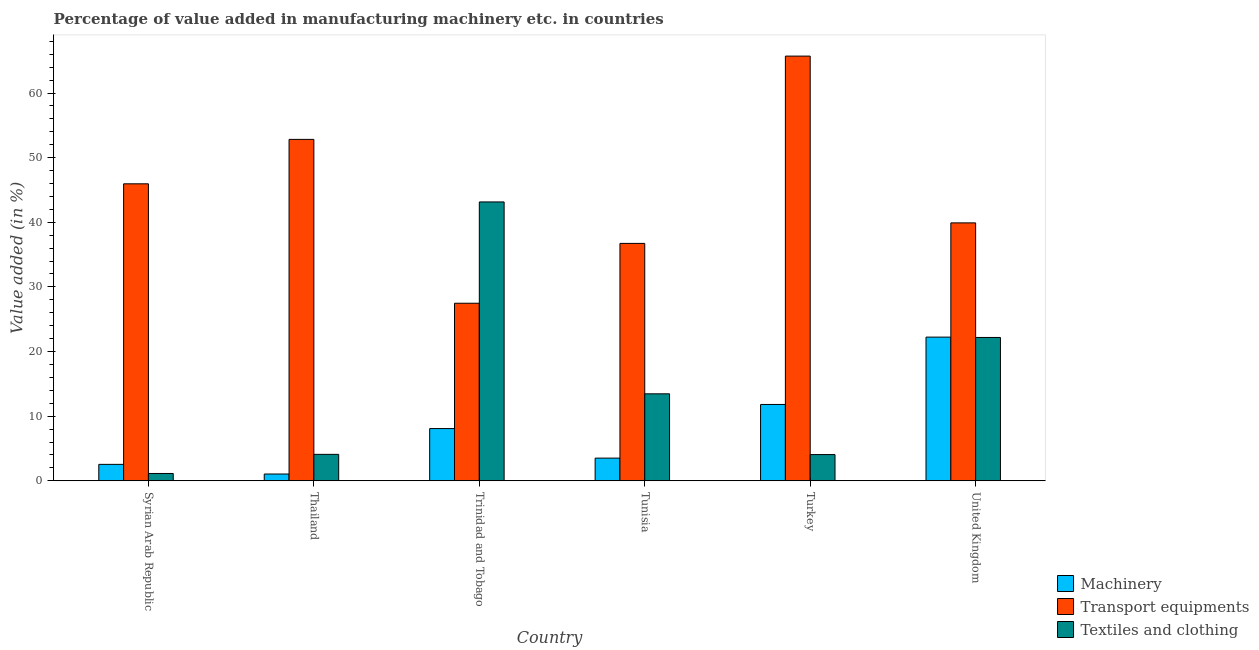How many groups of bars are there?
Provide a short and direct response. 6. Are the number of bars per tick equal to the number of legend labels?
Provide a short and direct response. Yes. Are the number of bars on each tick of the X-axis equal?
Make the answer very short. Yes. How many bars are there on the 5th tick from the right?
Offer a terse response. 3. What is the label of the 4th group of bars from the left?
Provide a succinct answer. Tunisia. In how many cases, is the number of bars for a given country not equal to the number of legend labels?
Ensure brevity in your answer.  0. What is the value added in manufacturing machinery in Trinidad and Tobago?
Give a very brief answer. 8.08. Across all countries, what is the maximum value added in manufacturing textile and clothing?
Your answer should be very brief. 43.15. Across all countries, what is the minimum value added in manufacturing transport equipments?
Offer a terse response. 27.47. In which country was the value added in manufacturing transport equipments maximum?
Your answer should be compact. Turkey. In which country was the value added in manufacturing machinery minimum?
Provide a succinct answer. Thailand. What is the total value added in manufacturing textile and clothing in the graph?
Provide a short and direct response. 88.06. What is the difference between the value added in manufacturing transport equipments in Syrian Arab Republic and that in Thailand?
Make the answer very short. -6.88. What is the difference between the value added in manufacturing textile and clothing in Syrian Arab Republic and the value added in manufacturing machinery in Turkey?
Keep it short and to the point. -10.68. What is the average value added in manufacturing transport equipments per country?
Make the answer very short. 44.77. What is the difference between the value added in manufacturing transport equipments and value added in manufacturing machinery in Tunisia?
Offer a very short reply. 33.23. In how many countries, is the value added in manufacturing textile and clothing greater than 60 %?
Give a very brief answer. 0. What is the ratio of the value added in manufacturing machinery in Syrian Arab Republic to that in Tunisia?
Ensure brevity in your answer.  0.72. Is the value added in manufacturing machinery in Syrian Arab Republic less than that in Tunisia?
Ensure brevity in your answer.  Yes. What is the difference between the highest and the second highest value added in manufacturing textile and clothing?
Your answer should be compact. 20.97. What is the difference between the highest and the lowest value added in manufacturing machinery?
Offer a terse response. 21.19. Is the sum of the value added in manufacturing textile and clothing in Syrian Arab Republic and Trinidad and Tobago greater than the maximum value added in manufacturing transport equipments across all countries?
Offer a very short reply. No. What does the 3rd bar from the left in Trinidad and Tobago represents?
Keep it short and to the point. Textiles and clothing. What does the 2nd bar from the right in United Kingdom represents?
Offer a very short reply. Transport equipments. How many bars are there?
Your answer should be compact. 18. Are all the bars in the graph horizontal?
Make the answer very short. No. How many countries are there in the graph?
Make the answer very short. 6. What is the difference between two consecutive major ticks on the Y-axis?
Your answer should be very brief. 10. Are the values on the major ticks of Y-axis written in scientific E-notation?
Give a very brief answer. No. Does the graph contain any zero values?
Provide a succinct answer. No. Does the graph contain grids?
Your response must be concise. No. Where does the legend appear in the graph?
Your answer should be compact. Bottom right. What is the title of the graph?
Ensure brevity in your answer.  Percentage of value added in manufacturing machinery etc. in countries. What is the label or title of the X-axis?
Provide a short and direct response. Country. What is the label or title of the Y-axis?
Make the answer very short. Value added (in %). What is the Value added (in %) of Machinery in Syrian Arab Republic?
Offer a very short reply. 2.54. What is the Value added (in %) in Transport equipments in Syrian Arab Republic?
Ensure brevity in your answer.  45.95. What is the Value added (in %) in Textiles and clothing in Syrian Arab Republic?
Your response must be concise. 1.13. What is the Value added (in %) of Machinery in Thailand?
Your answer should be compact. 1.05. What is the Value added (in %) in Transport equipments in Thailand?
Offer a terse response. 52.83. What is the Value added (in %) in Textiles and clothing in Thailand?
Offer a terse response. 4.09. What is the Value added (in %) of Machinery in Trinidad and Tobago?
Make the answer very short. 8.08. What is the Value added (in %) of Transport equipments in Trinidad and Tobago?
Provide a succinct answer. 27.47. What is the Value added (in %) in Textiles and clothing in Trinidad and Tobago?
Provide a succinct answer. 43.15. What is the Value added (in %) of Machinery in Tunisia?
Your answer should be very brief. 3.51. What is the Value added (in %) in Transport equipments in Tunisia?
Provide a short and direct response. 36.73. What is the Value added (in %) of Textiles and clothing in Tunisia?
Give a very brief answer. 13.46. What is the Value added (in %) in Machinery in Turkey?
Give a very brief answer. 11.81. What is the Value added (in %) of Transport equipments in Turkey?
Give a very brief answer. 65.71. What is the Value added (in %) in Textiles and clothing in Turkey?
Give a very brief answer. 4.06. What is the Value added (in %) in Machinery in United Kingdom?
Provide a succinct answer. 22.23. What is the Value added (in %) in Transport equipments in United Kingdom?
Your response must be concise. 39.91. What is the Value added (in %) in Textiles and clothing in United Kingdom?
Provide a short and direct response. 22.18. Across all countries, what is the maximum Value added (in %) of Machinery?
Your answer should be compact. 22.23. Across all countries, what is the maximum Value added (in %) of Transport equipments?
Ensure brevity in your answer.  65.71. Across all countries, what is the maximum Value added (in %) of Textiles and clothing?
Your answer should be compact. 43.15. Across all countries, what is the minimum Value added (in %) of Machinery?
Provide a short and direct response. 1.05. Across all countries, what is the minimum Value added (in %) in Transport equipments?
Provide a succinct answer. 27.47. Across all countries, what is the minimum Value added (in %) of Textiles and clothing?
Keep it short and to the point. 1.13. What is the total Value added (in %) of Machinery in the graph?
Ensure brevity in your answer.  49.22. What is the total Value added (in %) of Transport equipments in the graph?
Your answer should be very brief. 268.61. What is the total Value added (in %) of Textiles and clothing in the graph?
Provide a succinct answer. 88.06. What is the difference between the Value added (in %) of Machinery in Syrian Arab Republic and that in Thailand?
Offer a terse response. 1.49. What is the difference between the Value added (in %) in Transport equipments in Syrian Arab Republic and that in Thailand?
Your answer should be very brief. -6.88. What is the difference between the Value added (in %) in Textiles and clothing in Syrian Arab Republic and that in Thailand?
Make the answer very short. -2.96. What is the difference between the Value added (in %) in Machinery in Syrian Arab Republic and that in Trinidad and Tobago?
Keep it short and to the point. -5.54. What is the difference between the Value added (in %) in Transport equipments in Syrian Arab Republic and that in Trinidad and Tobago?
Ensure brevity in your answer.  18.48. What is the difference between the Value added (in %) of Textiles and clothing in Syrian Arab Republic and that in Trinidad and Tobago?
Ensure brevity in your answer.  -42.02. What is the difference between the Value added (in %) in Machinery in Syrian Arab Republic and that in Tunisia?
Your answer should be very brief. -0.97. What is the difference between the Value added (in %) in Transport equipments in Syrian Arab Republic and that in Tunisia?
Offer a very short reply. 9.22. What is the difference between the Value added (in %) of Textiles and clothing in Syrian Arab Republic and that in Tunisia?
Ensure brevity in your answer.  -12.32. What is the difference between the Value added (in %) in Machinery in Syrian Arab Republic and that in Turkey?
Your answer should be very brief. -9.27. What is the difference between the Value added (in %) of Transport equipments in Syrian Arab Republic and that in Turkey?
Your answer should be very brief. -19.76. What is the difference between the Value added (in %) in Textiles and clothing in Syrian Arab Republic and that in Turkey?
Give a very brief answer. -2.92. What is the difference between the Value added (in %) of Machinery in Syrian Arab Republic and that in United Kingdom?
Provide a succinct answer. -19.69. What is the difference between the Value added (in %) of Transport equipments in Syrian Arab Republic and that in United Kingdom?
Give a very brief answer. 6.04. What is the difference between the Value added (in %) of Textiles and clothing in Syrian Arab Republic and that in United Kingdom?
Provide a short and direct response. -21.05. What is the difference between the Value added (in %) of Machinery in Thailand and that in Trinidad and Tobago?
Your answer should be compact. -7.03. What is the difference between the Value added (in %) in Transport equipments in Thailand and that in Trinidad and Tobago?
Ensure brevity in your answer.  25.36. What is the difference between the Value added (in %) of Textiles and clothing in Thailand and that in Trinidad and Tobago?
Your response must be concise. -39.06. What is the difference between the Value added (in %) in Machinery in Thailand and that in Tunisia?
Ensure brevity in your answer.  -2.46. What is the difference between the Value added (in %) in Transport equipments in Thailand and that in Tunisia?
Offer a very short reply. 16.1. What is the difference between the Value added (in %) in Textiles and clothing in Thailand and that in Tunisia?
Keep it short and to the point. -9.36. What is the difference between the Value added (in %) in Machinery in Thailand and that in Turkey?
Offer a terse response. -10.76. What is the difference between the Value added (in %) in Transport equipments in Thailand and that in Turkey?
Provide a short and direct response. -12.88. What is the difference between the Value added (in %) of Textiles and clothing in Thailand and that in Turkey?
Provide a short and direct response. 0.03. What is the difference between the Value added (in %) in Machinery in Thailand and that in United Kingdom?
Your response must be concise. -21.19. What is the difference between the Value added (in %) in Transport equipments in Thailand and that in United Kingdom?
Make the answer very short. 12.92. What is the difference between the Value added (in %) of Textiles and clothing in Thailand and that in United Kingdom?
Your answer should be compact. -18.09. What is the difference between the Value added (in %) of Machinery in Trinidad and Tobago and that in Tunisia?
Make the answer very short. 4.57. What is the difference between the Value added (in %) of Transport equipments in Trinidad and Tobago and that in Tunisia?
Your answer should be very brief. -9.26. What is the difference between the Value added (in %) of Textiles and clothing in Trinidad and Tobago and that in Tunisia?
Provide a succinct answer. 29.69. What is the difference between the Value added (in %) in Machinery in Trinidad and Tobago and that in Turkey?
Make the answer very short. -3.73. What is the difference between the Value added (in %) of Transport equipments in Trinidad and Tobago and that in Turkey?
Ensure brevity in your answer.  -38.24. What is the difference between the Value added (in %) in Textiles and clothing in Trinidad and Tobago and that in Turkey?
Give a very brief answer. 39.09. What is the difference between the Value added (in %) in Machinery in Trinidad and Tobago and that in United Kingdom?
Your answer should be compact. -14.15. What is the difference between the Value added (in %) of Transport equipments in Trinidad and Tobago and that in United Kingdom?
Your answer should be compact. -12.44. What is the difference between the Value added (in %) in Textiles and clothing in Trinidad and Tobago and that in United Kingdom?
Provide a succinct answer. 20.97. What is the difference between the Value added (in %) in Machinery in Tunisia and that in Turkey?
Make the answer very short. -8.3. What is the difference between the Value added (in %) of Transport equipments in Tunisia and that in Turkey?
Offer a terse response. -28.98. What is the difference between the Value added (in %) of Textiles and clothing in Tunisia and that in Turkey?
Provide a short and direct response. 9.4. What is the difference between the Value added (in %) in Machinery in Tunisia and that in United Kingdom?
Your response must be concise. -18.73. What is the difference between the Value added (in %) of Transport equipments in Tunisia and that in United Kingdom?
Make the answer very short. -3.17. What is the difference between the Value added (in %) of Textiles and clothing in Tunisia and that in United Kingdom?
Provide a succinct answer. -8.72. What is the difference between the Value added (in %) of Machinery in Turkey and that in United Kingdom?
Ensure brevity in your answer.  -10.42. What is the difference between the Value added (in %) in Transport equipments in Turkey and that in United Kingdom?
Offer a terse response. 25.81. What is the difference between the Value added (in %) of Textiles and clothing in Turkey and that in United Kingdom?
Your answer should be compact. -18.12. What is the difference between the Value added (in %) in Machinery in Syrian Arab Republic and the Value added (in %) in Transport equipments in Thailand?
Give a very brief answer. -50.29. What is the difference between the Value added (in %) in Machinery in Syrian Arab Republic and the Value added (in %) in Textiles and clothing in Thailand?
Offer a very short reply. -1.55. What is the difference between the Value added (in %) of Transport equipments in Syrian Arab Republic and the Value added (in %) of Textiles and clothing in Thailand?
Your answer should be very brief. 41.86. What is the difference between the Value added (in %) in Machinery in Syrian Arab Republic and the Value added (in %) in Transport equipments in Trinidad and Tobago?
Your answer should be compact. -24.93. What is the difference between the Value added (in %) of Machinery in Syrian Arab Republic and the Value added (in %) of Textiles and clothing in Trinidad and Tobago?
Your response must be concise. -40.61. What is the difference between the Value added (in %) of Transport equipments in Syrian Arab Republic and the Value added (in %) of Textiles and clothing in Trinidad and Tobago?
Keep it short and to the point. 2.8. What is the difference between the Value added (in %) in Machinery in Syrian Arab Republic and the Value added (in %) in Transport equipments in Tunisia?
Make the answer very short. -34.19. What is the difference between the Value added (in %) of Machinery in Syrian Arab Republic and the Value added (in %) of Textiles and clothing in Tunisia?
Your answer should be compact. -10.92. What is the difference between the Value added (in %) of Transport equipments in Syrian Arab Republic and the Value added (in %) of Textiles and clothing in Tunisia?
Make the answer very short. 32.5. What is the difference between the Value added (in %) of Machinery in Syrian Arab Republic and the Value added (in %) of Transport equipments in Turkey?
Your answer should be very brief. -63.17. What is the difference between the Value added (in %) in Machinery in Syrian Arab Republic and the Value added (in %) in Textiles and clothing in Turkey?
Give a very brief answer. -1.52. What is the difference between the Value added (in %) in Transport equipments in Syrian Arab Republic and the Value added (in %) in Textiles and clothing in Turkey?
Your answer should be very brief. 41.9. What is the difference between the Value added (in %) in Machinery in Syrian Arab Republic and the Value added (in %) in Transport equipments in United Kingdom?
Provide a short and direct response. -37.37. What is the difference between the Value added (in %) of Machinery in Syrian Arab Republic and the Value added (in %) of Textiles and clothing in United Kingdom?
Provide a short and direct response. -19.64. What is the difference between the Value added (in %) in Transport equipments in Syrian Arab Republic and the Value added (in %) in Textiles and clothing in United Kingdom?
Provide a short and direct response. 23.77. What is the difference between the Value added (in %) of Machinery in Thailand and the Value added (in %) of Transport equipments in Trinidad and Tobago?
Your answer should be very brief. -26.43. What is the difference between the Value added (in %) in Machinery in Thailand and the Value added (in %) in Textiles and clothing in Trinidad and Tobago?
Make the answer very short. -42.1. What is the difference between the Value added (in %) of Transport equipments in Thailand and the Value added (in %) of Textiles and clothing in Trinidad and Tobago?
Make the answer very short. 9.68. What is the difference between the Value added (in %) in Machinery in Thailand and the Value added (in %) in Transport equipments in Tunisia?
Ensure brevity in your answer.  -35.69. What is the difference between the Value added (in %) in Machinery in Thailand and the Value added (in %) in Textiles and clothing in Tunisia?
Offer a very short reply. -12.41. What is the difference between the Value added (in %) in Transport equipments in Thailand and the Value added (in %) in Textiles and clothing in Tunisia?
Your response must be concise. 39.37. What is the difference between the Value added (in %) in Machinery in Thailand and the Value added (in %) in Transport equipments in Turkey?
Your answer should be compact. -64.67. What is the difference between the Value added (in %) of Machinery in Thailand and the Value added (in %) of Textiles and clothing in Turkey?
Offer a terse response. -3.01. What is the difference between the Value added (in %) of Transport equipments in Thailand and the Value added (in %) of Textiles and clothing in Turkey?
Your answer should be very brief. 48.77. What is the difference between the Value added (in %) of Machinery in Thailand and the Value added (in %) of Transport equipments in United Kingdom?
Offer a very short reply. -38.86. What is the difference between the Value added (in %) in Machinery in Thailand and the Value added (in %) in Textiles and clothing in United Kingdom?
Provide a succinct answer. -21.13. What is the difference between the Value added (in %) in Transport equipments in Thailand and the Value added (in %) in Textiles and clothing in United Kingdom?
Your answer should be very brief. 30.65. What is the difference between the Value added (in %) of Machinery in Trinidad and Tobago and the Value added (in %) of Transport equipments in Tunisia?
Provide a succinct answer. -28.65. What is the difference between the Value added (in %) in Machinery in Trinidad and Tobago and the Value added (in %) in Textiles and clothing in Tunisia?
Offer a very short reply. -5.38. What is the difference between the Value added (in %) of Transport equipments in Trinidad and Tobago and the Value added (in %) of Textiles and clothing in Tunisia?
Provide a succinct answer. 14.02. What is the difference between the Value added (in %) of Machinery in Trinidad and Tobago and the Value added (in %) of Transport equipments in Turkey?
Provide a short and direct response. -57.63. What is the difference between the Value added (in %) of Machinery in Trinidad and Tobago and the Value added (in %) of Textiles and clothing in Turkey?
Offer a terse response. 4.02. What is the difference between the Value added (in %) in Transport equipments in Trinidad and Tobago and the Value added (in %) in Textiles and clothing in Turkey?
Make the answer very short. 23.42. What is the difference between the Value added (in %) in Machinery in Trinidad and Tobago and the Value added (in %) in Transport equipments in United Kingdom?
Offer a terse response. -31.83. What is the difference between the Value added (in %) in Machinery in Trinidad and Tobago and the Value added (in %) in Textiles and clothing in United Kingdom?
Keep it short and to the point. -14.1. What is the difference between the Value added (in %) of Transport equipments in Trinidad and Tobago and the Value added (in %) of Textiles and clothing in United Kingdom?
Your answer should be compact. 5.3. What is the difference between the Value added (in %) in Machinery in Tunisia and the Value added (in %) in Transport equipments in Turkey?
Ensure brevity in your answer.  -62.21. What is the difference between the Value added (in %) in Machinery in Tunisia and the Value added (in %) in Textiles and clothing in Turkey?
Ensure brevity in your answer.  -0.55. What is the difference between the Value added (in %) of Transport equipments in Tunisia and the Value added (in %) of Textiles and clothing in Turkey?
Your response must be concise. 32.68. What is the difference between the Value added (in %) of Machinery in Tunisia and the Value added (in %) of Transport equipments in United Kingdom?
Give a very brief answer. -36.4. What is the difference between the Value added (in %) in Machinery in Tunisia and the Value added (in %) in Textiles and clothing in United Kingdom?
Keep it short and to the point. -18.67. What is the difference between the Value added (in %) of Transport equipments in Tunisia and the Value added (in %) of Textiles and clothing in United Kingdom?
Offer a terse response. 14.56. What is the difference between the Value added (in %) in Machinery in Turkey and the Value added (in %) in Transport equipments in United Kingdom?
Your answer should be compact. -28.1. What is the difference between the Value added (in %) of Machinery in Turkey and the Value added (in %) of Textiles and clothing in United Kingdom?
Give a very brief answer. -10.37. What is the difference between the Value added (in %) in Transport equipments in Turkey and the Value added (in %) in Textiles and clothing in United Kingdom?
Make the answer very short. 43.54. What is the average Value added (in %) in Machinery per country?
Offer a very short reply. 8.2. What is the average Value added (in %) in Transport equipments per country?
Provide a short and direct response. 44.77. What is the average Value added (in %) of Textiles and clothing per country?
Your answer should be compact. 14.68. What is the difference between the Value added (in %) of Machinery and Value added (in %) of Transport equipments in Syrian Arab Republic?
Make the answer very short. -43.41. What is the difference between the Value added (in %) of Machinery and Value added (in %) of Textiles and clothing in Syrian Arab Republic?
Provide a succinct answer. 1.41. What is the difference between the Value added (in %) of Transport equipments and Value added (in %) of Textiles and clothing in Syrian Arab Republic?
Ensure brevity in your answer.  44.82. What is the difference between the Value added (in %) in Machinery and Value added (in %) in Transport equipments in Thailand?
Offer a very short reply. -51.78. What is the difference between the Value added (in %) of Machinery and Value added (in %) of Textiles and clothing in Thailand?
Make the answer very short. -3.04. What is the difference between the Value added (in %) in Transport equipments and Value added (in %) in Textiles and clothing in Thailand?
Your answer should be compact. 48.74. What is the difference between the Value added (in %) of Machinery and Value added (in %) of Transport equipments in Trinidad and Tobago?
Your response must be concise. -19.39. What is the difference between the Value added (in %) in Machinery and Value added (in %) in Textiles and clothing in Trinidad and Tobago?
Your answer should be compact. -35.07. What is the difference between the Value added (in %) in Transport equipments and Value added (in %) in Textiles and clothing in Trinidad and Tobago?
Make the answer very short. -15.68. What is the difference between the Value added (in %) in Machinery and Value added (in %) in Transport equipments in Tunisia?
Give a very brief answer. -33.23. What is the difference between the Value added (in %) of Machinery and Value added (in %) of Textiles and clothing in Tunisia?
Your answer should be compact. -9.95. What is the difference between the Value added (in %) of Transport equipments and Value added (in %) of Textiles and clothing in Tunisia?
Your answer should be very brief. 23.28. What is the difference between the Value added (in %) in Machinery and Value added (in %) in Transport equipments in Turkey?
Your answer should be compact. -53.9. What is the difference between the Value added (in %) in Machinery and Value added (in %) in Textiles and clothing in Turkey?
Keep it short and to the point. 7.75. What is the difference between the Value added (in %) of Transport equipments and Value added (in %) of Textiles and clothing in Turkey?
Your response must be concise. 61.66. What is the difference between the Value added (in %) of Machinery and Value added (in %) of Transport equipments in United Kingdom?
Give a very brief answer. -17.68. What is the difference between the Value added (in %) of Machinery and Value added (in %) of Textiles and clothing in United Kingdom?
Offer a terse response. 0.05. What is the difference between the Value added (in %) of Transport equipments and Value added (in %) of Textiles and clothing in United Kingdom?
Your response must be concise. 17.73. What is the ratio of the Value added (in %) in Machinery in Syrian Arab Republic to that in Thailand?
Offer a terse response. 2.43. What is the ratio of the Value added (in %) in Transport equipments in Syrian Arab Republic to that in Thailand?
Your answer should be very brief. 0.87. What is the ratio of the Value added (in %) of Textiles and clothing in Syrian Arab Republic to that in Thailand?
Give a very brief answer. 0.28. What is the ratio of the Value added (in %) in Machinery in Syrian Arab Republic to that in Trinidad and Tobago?
Your response must be concise. 0.31. What is the ratio of the Value added (in %) of Transport equipments in Syrian Arab Republic to that in Trinidad and Tobago?
Your response must be concise. 1.67. What is the ratio of the Value added (in %) of Textiles and clothing in Syrian Arab Republic to that in Trinidad and Tobago?
Your answer should be compact. 0.03. What is the ratio of the Value added (in %) in Machinery in Syrian Arab Republic to that in Tunisia?
Make the answer very short. 0.72. What is the ratio of the Value added (in %) in Transport equipments in Syrian Arab Republic to that in Tunisia?
Your answer should be compact. 1.25. What is the ratio of the Value added (in %) in Textiles and clothing in Syrian Arab Republic to that in Tunisia?
Offer a very short reply. 0.08. What is the ratio of the Value added (in %) of Machinery in Syrian Arab Republic to that in Turkey?
Offer a terse response. 0.22. What is the ratio of the Value added (in %) of Transport equipments in Syrian Arab Republic to that in Turkey?
Provide a succinct answer. 0.7. What is the ratio of the Value added (in %) of Textiles and clothing in Syrian Arab Republic to that in Turkey?
Keep it short and to the point. 0.28. What is the ratio of the Value added (in %) in Machinery in Syrian Arab Republic to that in United Kingdom?
Make the answer very short. 0.11. What is the ratio of the Value added (in %) in Transport equipments in Syrian Arab Republic to that in United Kingdom?
Provide a succinct answer. 1.15. What is the ratio of the Value added (in %) in Textiles and clothing in Syrian Arab Republic to that in United Kingdom?
Make the answer very short. 0.05. What is the ratio of the Value added (in %) in Machinery in Thailand to that in Trinidad and Tobago?
Your answer should be very brief. 0.13. What is the ratio of the Value added (in %) in Transport equipments in Thailand to that in Trinidad and Tobago?
Give a very brief answer. 1.92. What is the ratio of the Value added (in %) in Textiles and clothing in Thailand to that in Trinidad and Tobago?
Give a very brief answer. 0.09. What is the ratio of the Value added (in %) in Machinery in Thailand to that in Tunisia?
Ensure brevity in your answer.  0.3. What is the ratio of the Value added (in %) of Transport equipments in Thailand to that in Tunisia?
Your answer should be compact. 1.44. What is the ratio of the Value added (in %) of Textiles and clothing in Thailand to that in Tunisia?
Offer a terse response. 0.3. What is the ratio of the Value added (in %) in Machinery in Thailand to that in Turkey?
Keep it short and to the point. 0.09. What is the ratio of the Value added (in %) of Transport equipments in Thailand to that in Turkey?
Provide a short and direct response. 0.8. What is the ratio of the Value added (in %) of Textiles and clothing in Thailand to that in Turkey?
Provide a succinct answer. 1.01. What is the ratio of the Value added (in %) of Machinery in Thailand to that in United Kingdom?
Offer a terse response. 0.05. What is the ratio of the Value added (in %) in Transport equipments in Thailand to that in United Kingdom?
Provide a short and direct response. 1.32. What is the ratio of the Value added (in %) in Textiles and clothing in Thailand to that in United Kingdom?
Keep it short and to the point. 0.18. What is the ratio of the Value added (in %) in Machinery in Trinidad and Tobago to that in Tunisia?
Your answer should be very brief. 2.3. What is the ratio of the Value added (in %) of Transport equipments in Trinidad and Tobago to that in Tunisia?
Your answer should be very brief. 0.75. What is the ratio of the Value added (in %) of Textiles and clothing in Trinidad and Tobago to that in Tunisia?
Offer a very short reply. 3.21. What is the ratio of the Value added (in %) in Machinery in Trinidad and Tobago to that in Turkey?
Provide a succinct answer. 0.68. What is the ratio of the Value added (in %) of Transport equipments in Trinidad and Tobago to that in Turkey?
Ensure brevity in your answer.  0.42. What is the ratio of the Value added (in %) of Textiles and clothing in Trinidad and Tobago to that in Turkey?
Offer a very short reply. 10.64. What is the ratio of the Value added (in %) of Machinery in Trinidad and Tobago to that in United Kingdom?
Your answer should be very brief. 0.36. What is the ratio of the Value added (in %) of Transport equipments in Trinidad and Tobago to that in United Kingdom?
Your response must be concise. 0.69. What is the ratio of the Value added (in %) of Textiles and clothing in Trinidad and Tobago to that in United Kingdom?
Offer a terse response. 1.95. What is the ratio of the Value added (in %) of Machinery in Tunisia to that in Turkey?
Your answer should be very brief. 0.3. What is the ratio of the Value added (in %) of Transport equipments in Tunisia to that in Turkey?
Offer a terse response. 0.56. What is the ratio of the Value added (in %) of Textiles and clothing in Tunisia to that in Turkey?
Your answer should be very brief. 3.32. What is the ratio of the Value added (in %) in Machinery in Tunisia to that in United Kingdom?
Your answer should be very brief. 0.16. What is the ratio of the Value added (in %) of Transport equipments in Tunisia to that in United Kingdom?
Your response must be concise. 0.92. What is the ratio of the Value added (in %) in Textiles and clothing in Tunisia to that in United Kingdom?
Offer a terse response. 0.61. What is the ratio of the Value added (in %) of Machinery in Turkey to that in United Kingdom?
Make the answer very short. 0.53. What is the ratio of the Value added (in %) in Transport equipments in Turkey to that in United Kingdom?
Give a very brief answer. 1.65. What is the ratio of the Value added (in %) of Textiles and clothing in Turkey to that in United Kingdom?
Keep it short and to the point. 0.18. What is the difference between the highest and the second highest Value added (in %) in Machinery?
Your response must be concise. 10.42. What is the difference between the highest and the second highest Value added (in %) in Transport equipments?
Give a very brief answer. 12.88. What is the difference between the highest and the second highest Value added (in %) of Textiles and clothing?
Your answer should be compact. 20.97. What is the difference between the highest and the lowest Value added (in %) of Machinery?
Your answer should be compact. 21.19. What is the difference between the highest and the lowest Value added (in %) in Transport equipments?
Provide a short and direct response. 38.24. What is the difference between the highest and the lowest Value added (in %) in Textiles and clothing?
Ensure brevity in your answer.  42.02. 